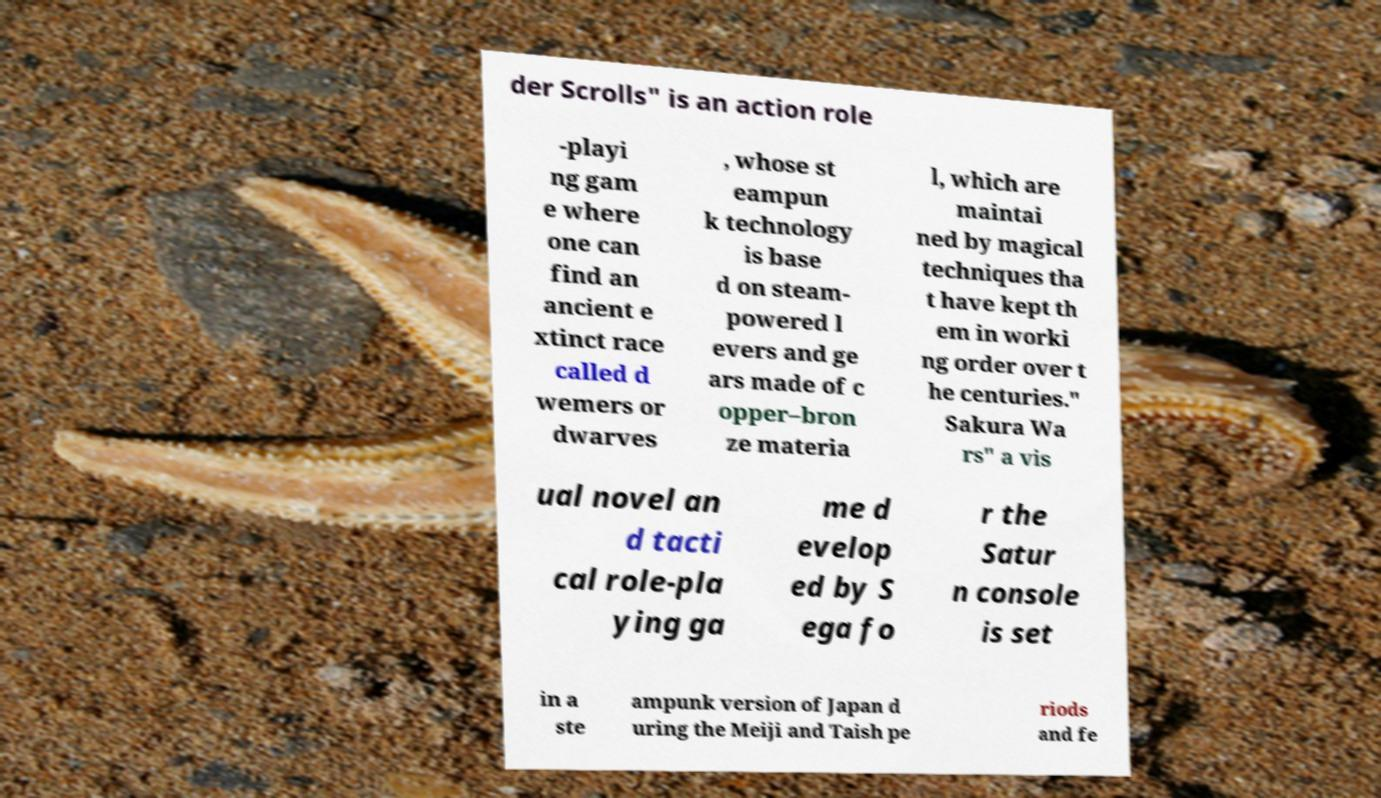Could you assist in decoding the text presented in this image and type it out clearly? der Scrolls" is an action role -playi ng gam e where one can find an ancient e xtinct race called d wemers or dwarves , whose st eampun k technology is base d on steam- powered l evers and ge ars made of c opper–bron ze materia l, which are maintai ned by magical techniques tha t have kept th em in worki ng order over t he centuries." Sakura Wa rs" a vis ual novel an d tacti cal role-pla ying ga me d evelop ed by S ega fo r the Satur n console is set in a ste ampunk version of Japan d uring the Meiji and Taish pe riods and fe 